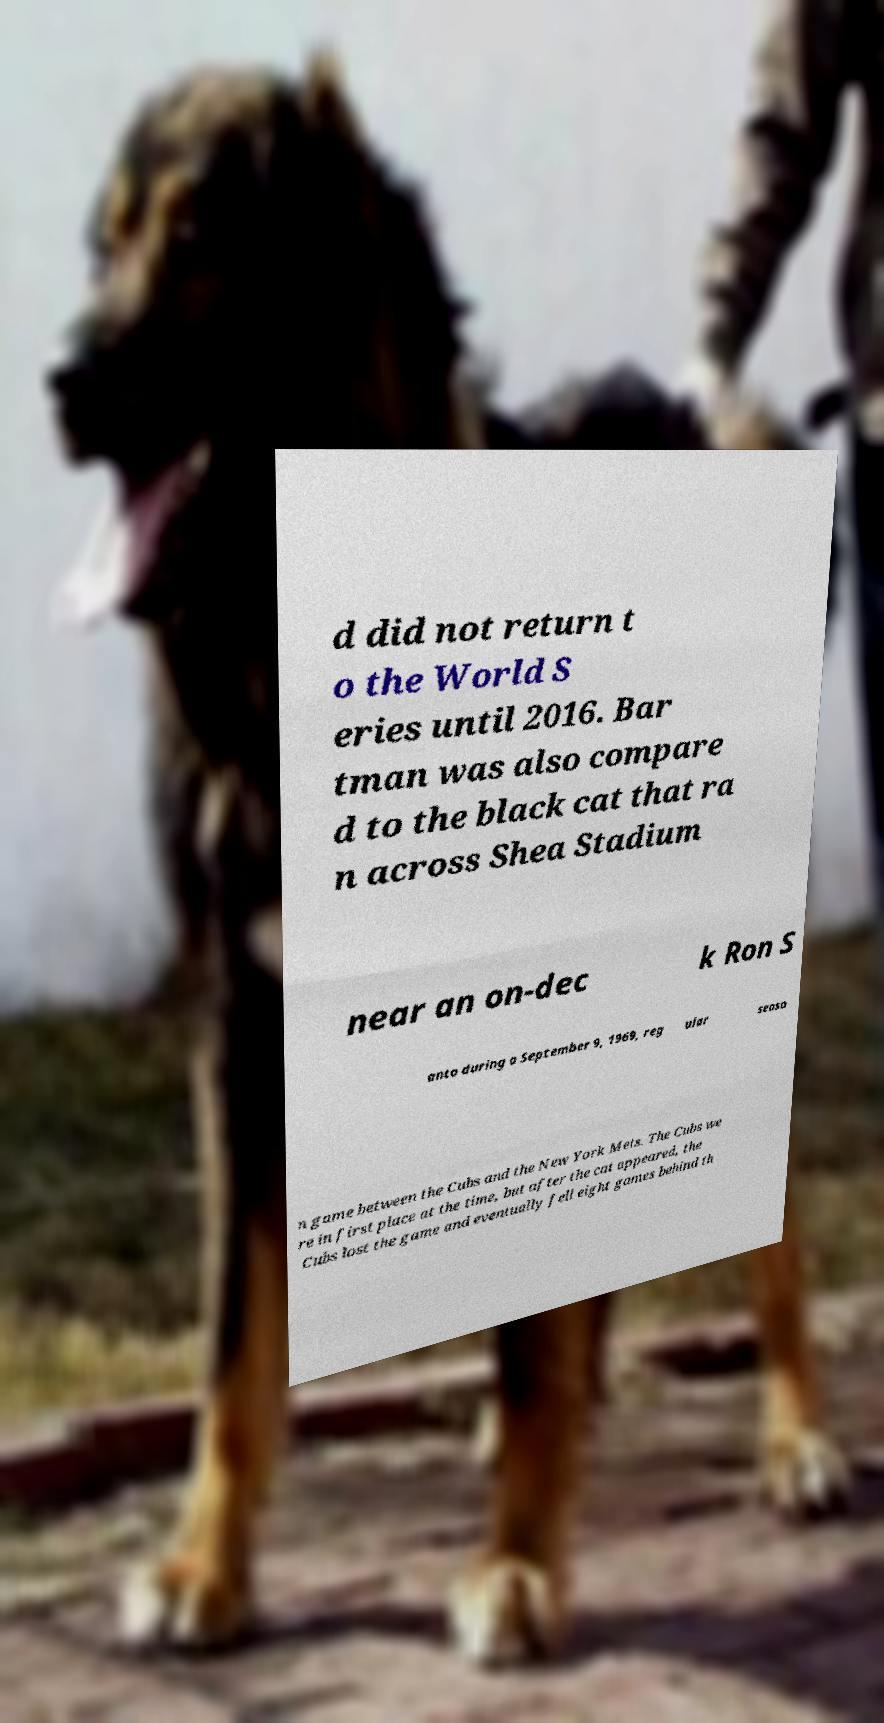What messages or text are displayed in this image? I need them in a readable, typed format. d did not return t o the World S eries until 2016. Bar tman was also compare d to the black cat that ra n across Shea Stadium near an on-dec k Ron S anto during a September 9, 1969, reg ular seaso n game between the Cubs and the New York Mets. The Cubs we re in first place at the time, but after the cat appeared, the Cubs lost the game and eventually fell eight games behind th 